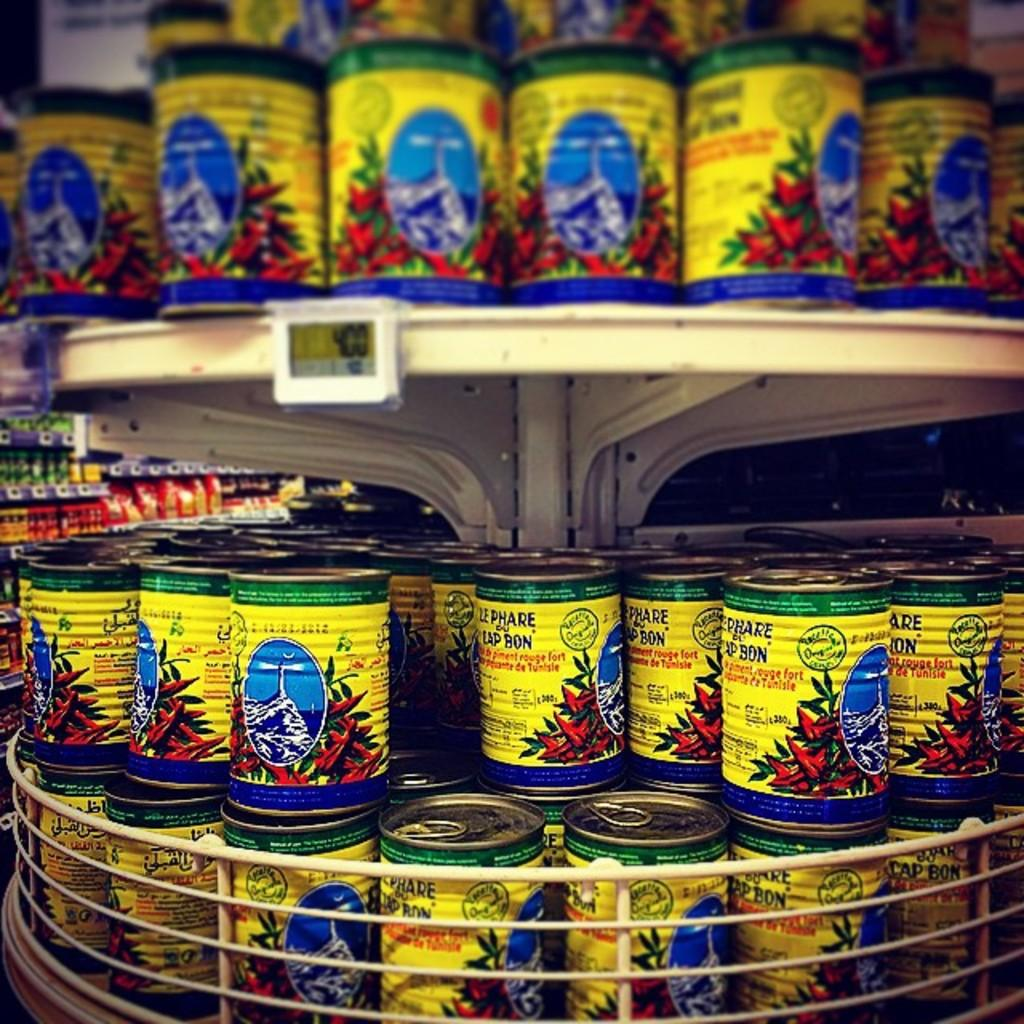What is the main structure in the image? There is a stand with objects placed on it. What other structure is present in the image? There is a rack with objects placed on it. Can you describe the objects on the stand? The provided facts do not specify the objects on the stand, so we cannot describe them. Can you describe the objects on the rack? The provided facts do not specify the objects on the rack, so we cannot describe them. How much money is being rewarded on the edge of the stand? There is no mention of money or an edge in the image, so we cannot answer this question. 